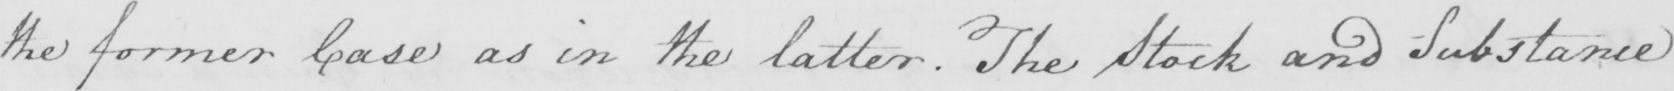What text is written in this handwritten line? the former Case as in the latter . The Stock and Substance 